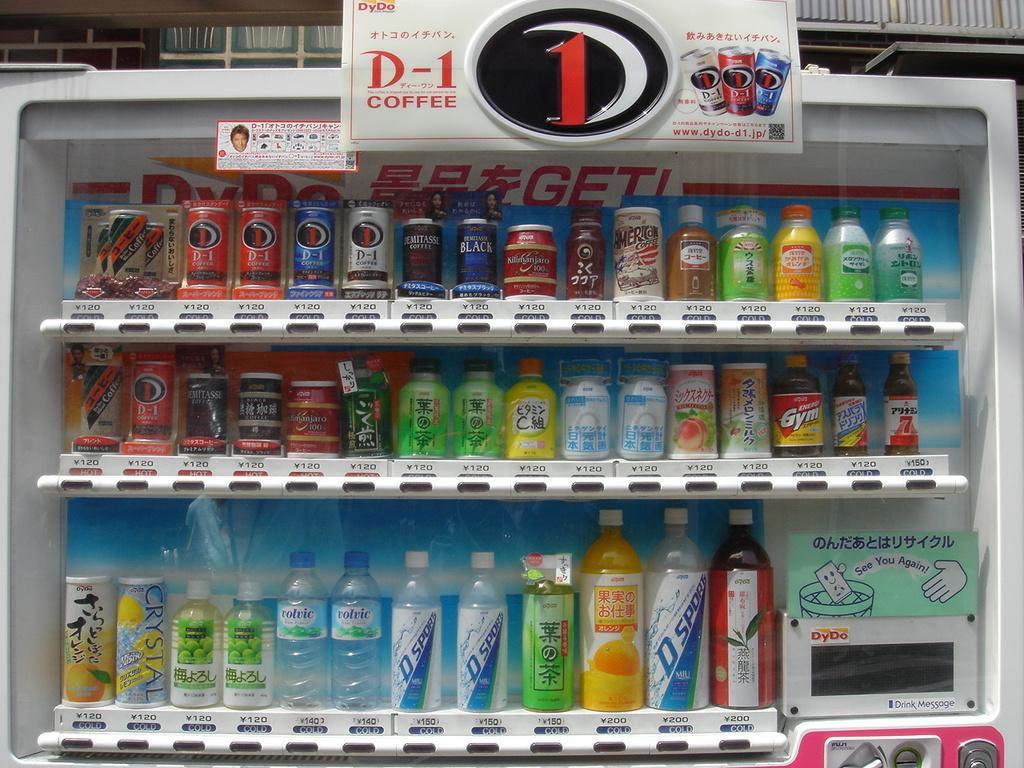<image>
Give a short and clear explanation of the subsequent image. A collection of drinks include names like Crystal, D-1, and Demitasse. 